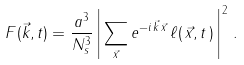<formula> <loc_0><loc_0><loc_500><loc_500>F ( \vec { k } , t ) = \frac { a ^ { 3 } } { N _ { s } ^ { 3 } } \left | \, \sum _ { \vec { x } } e ^ { - i \, \vec { k } \, \vec { x } } \, \ell ( \, \vec { x } , t \, ) \, \right | ^ { 2 } \, .</formula> 